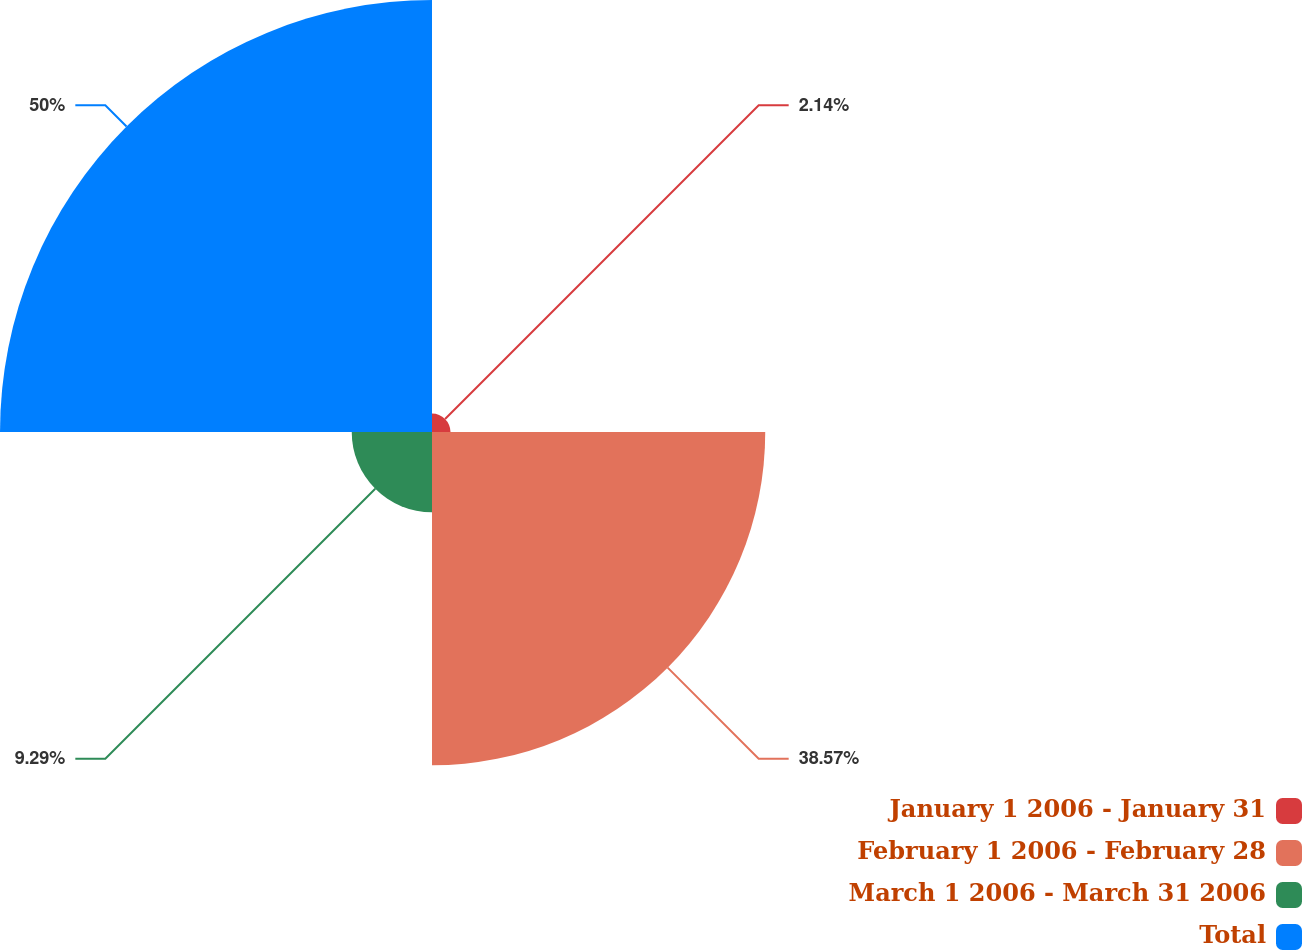Convert chart to OTSL. <chart><loc_0><loc_0><loc_500><loc_500><pie_chart><fcel>January 1 2006 - January 31<fcel>February 1 2006 - February 28<fcel>March 1 2006 - March 31 2006<fcel>Total<nl><fcel>2.14%<fcel>38.57%<fcel>9.29%<fcel>50.0%<nl></chart> 